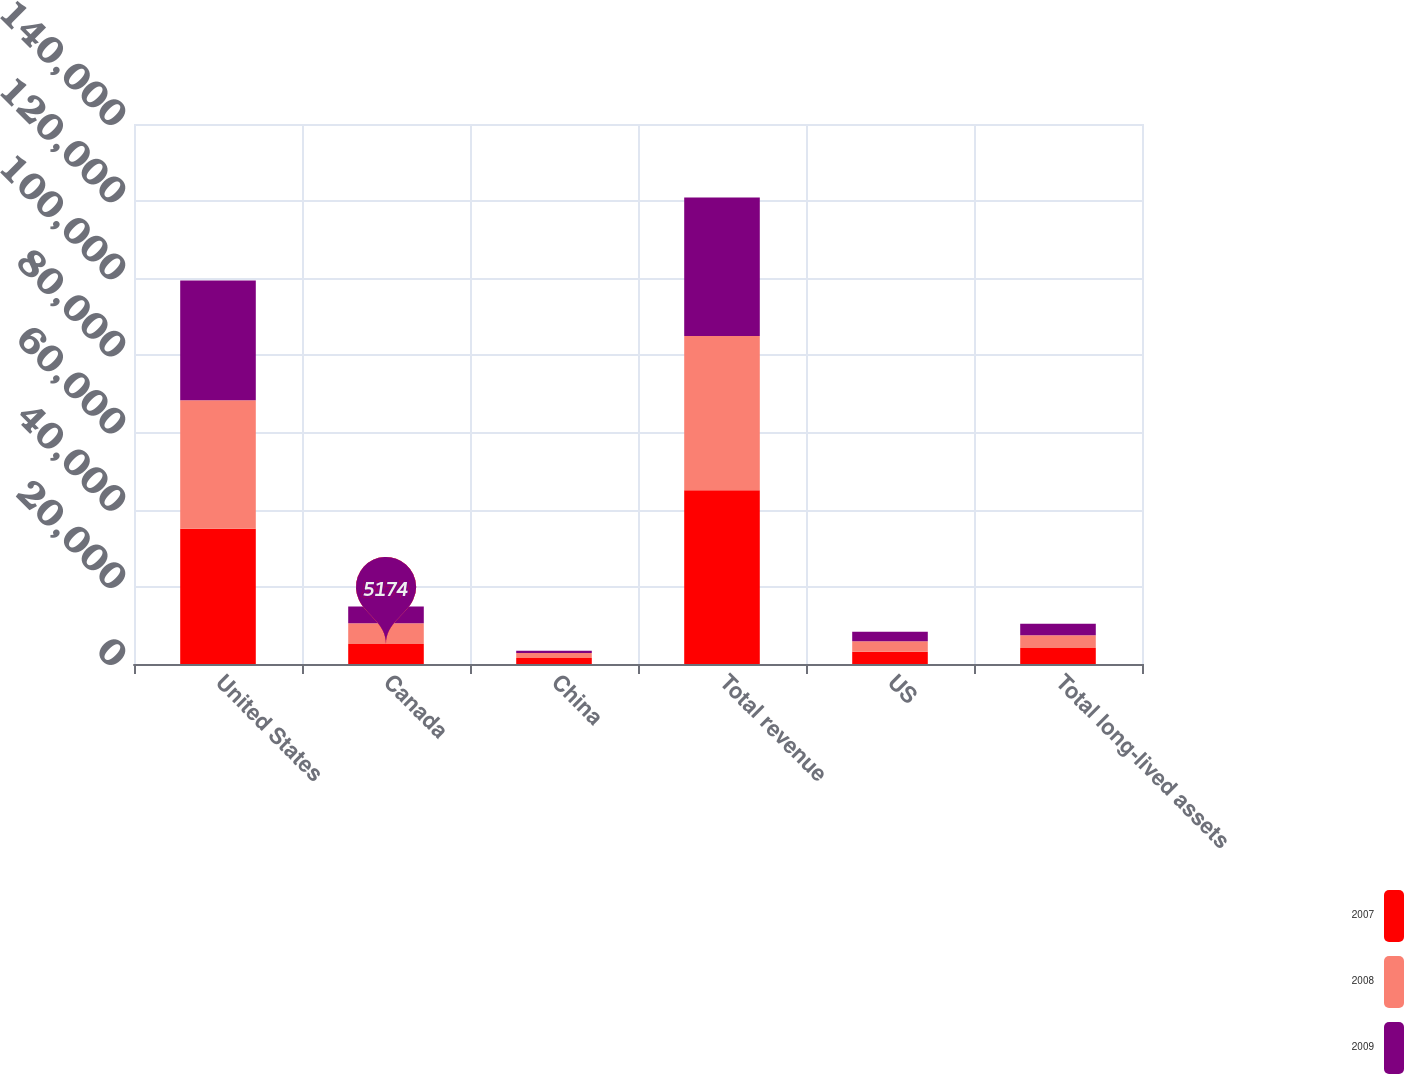Convert chart. <chart><loc_0><loc_0><loc_500><loc_500><stacked_bar_chart><ecel><fcel>United States<fcel>Canada<fcel>China<fcel>Total revenue<fcel>US<fcel>Total long-lived assets<nl><fcel>2007<fcel>35070<fcel>5174<fcel>1558<fcel>45015<fcel>3155<fcel>4174<nl><fcel>2008<fcel>33328<fcel>5386<fcel>1309<fcel>40023<fcel>2733<fcel>3306<nl><fcel>2009<fcel>31031<fcel>4340<fcel>563<fcel>35934<fcel>2487<fcel>2938<nl></chart> 